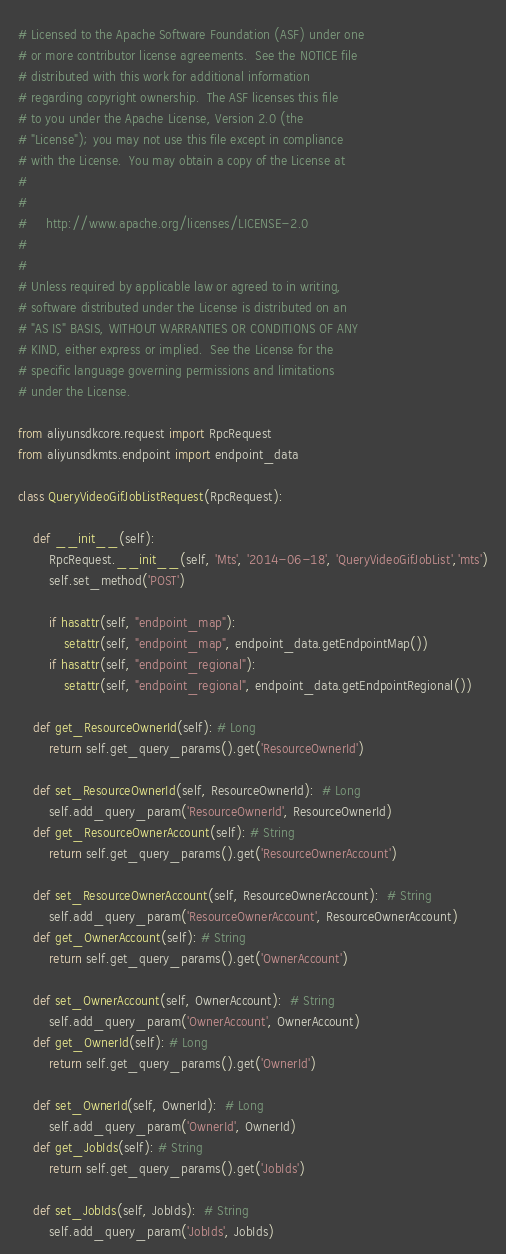Convert code to text. <code><loc_0><loc_0><loc_500><loc_500><_Python_># Licensed to the Apache Software Foundation (ASF) under one
# or more contributor license agreements.  See the NOTICE file
# distributed with this work for additional information
# regarding copyright ownership.  The ASF licenses this file
# to you under the Apache License, Version 2.0 (the
# "License"); you may not use this file except in compliance
# with the License.  You may obtain a copy of the License at
#
#
#     http://www.apache.org/licenses/LICENSE-2.0
#
#
# Unless required by applicable law or agreed to in writing,
# software distributed under the License is distributed on an
# "AS IS" BASIS, WITHOUT WARRANTIES OR CONDITIONS OF ANY
# KIND, either express or implied.  See the License for the
# specific language governing permissions and limitations
# under the License.

from aliyunsdkcore.request import RpcRequest
from aliyunsdkmts.endpoint import endpoint_data

class QueryVideoGifJobListRequest(RpcRequest):

	def __init__(self):
		RpcRequest.__init__(self, 'Mts', '2014-06-18', 'QueryVideoGifJobList','mts')
		self.set_method('POST')

		if hasattr(self, "endpoint_map"):
			setattr(self, "endpoint_map", endpoint_data.getEndpointMap())
		if hasattr(self, "endpoint_regional"):
			setattr(self, "endpoint_regional", endpoint_data.getEndpointRegional())

	def get_ResourceOwnerId(self): # Long
		return self.get_query_params().get('ResourceOwnerId')

	def set_ResourceOwnerId(self, ResourceOwnerId):  # Long
		self.add_query_param('ResourceOwnerId', ResourceOwnerId)
	def get_ResourceOwnerAccount(self): # String
		return self.get_query_params().get('ResourceOwnerAccount')

	def set_ResourceOwnerAccount(self, ResourceOwnerAccount):  # String
		self.add_query_param('ResourceOwnerAccount', ResourceOwnerAccount)
	def get_OwnerAccount(self): # String
		return self.get_query_params().get('OwnerAccount')

	def set_OwnerAccount(self, OwnerAccount):  # String
		self.add_query_param('OwnerAccount', OwnerAccount)
	def get_OwnerId(self): # Long
		return self.get_query_params().get('OwnerId')

	def set_OwnerId(self, OwnerId):  # Long
		self.add_query_param('OwnerId', OwnerId)
	def get_JobIds(self): # String
		return self.get_query_params().get('JobIds')

	def set_JobIds(self, JobIds):  # String
		self.add_query_param('JobIds', JobIds)
</code> 